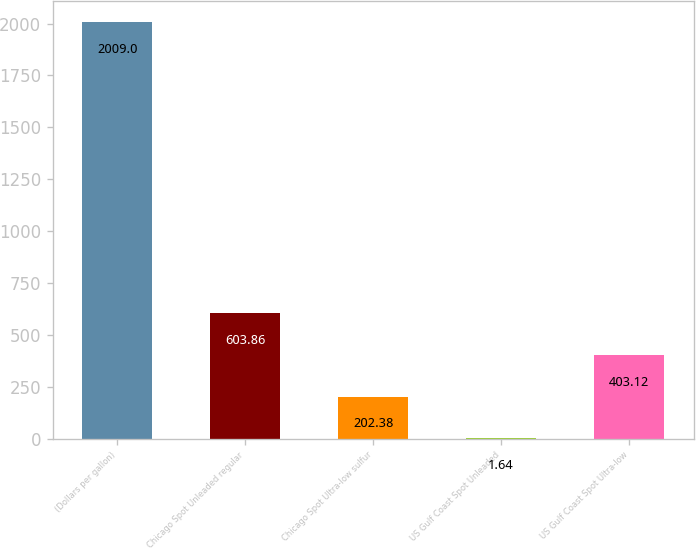Convert chart to OTSL. <chart><loc_0><loc_0><loc_500><loc_500><bar_chart><fcel>(Dollars per gallon)<fcel>Chicago Spot Unleaded regular<fcel>Chicago Spot Ultra-low sulfur<fcel>US Gulf Coast Spot Unleaded<fcel>US Gulf Coast Spot Ultra-low<nl><fcel>2009<fcel>603.86<fcel>202.38<fcel>1.64<fcel>403.12<nl></chart> 